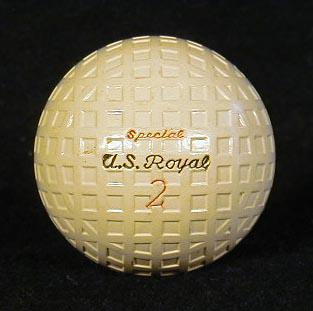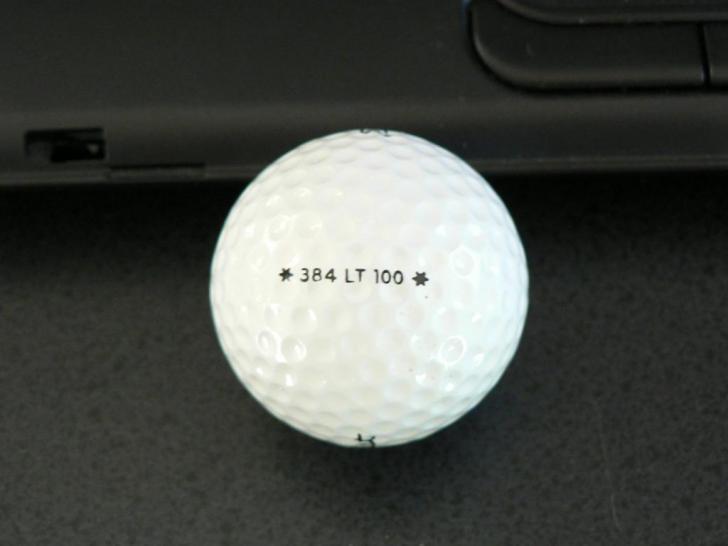The first image is the image on the left, the second image is the image on the right. For the images displayed, is the sentence "All balls are white and all balls have round-dimpled surfaces." factually correct? Answer yes or no. No. The first image is the image on the left, the second image is the image on the right. Evaluate the accuracy of this statement regarding the images: "The left and right image contains a total of two golf balls.". Is it true? Answer yes or no. Yes. 